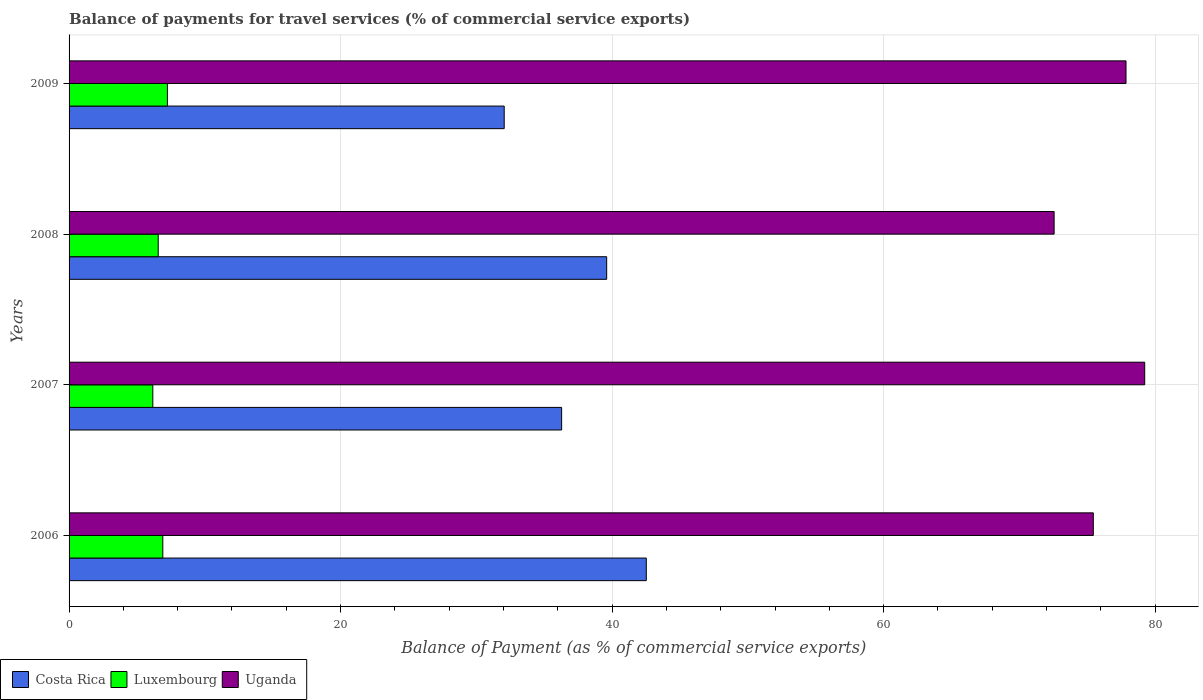How many different coloured bars are there?
Provide a short and direct response. 3. Are the number of bars per tick equal to the number of legend labels?
Ensure brevity in your answer.  Yes. Are the number of bars on each tick of the Y-axis equal?
Your response must be concise. Yes. How many bars are there on the 4th tick from the top?
Provide a succinct answer. 3. How many bars are there on the 1st tick from the bottom?
Provide a succinct answer. 3. What is the label of the 1st group of bars from the top?
Ensure brevity in your answer.  2009. What is the balance of payments for travel services in Costa Rica in 2008?
Your answer should be compact. 39.6. Across all years, what is the maximum balance of payments for travel services in Luxembourg?
Your answer should be compact. 7.24. Across all years, what is the minimum balance of payments for travel services in Luxembourg?
Provide a succinct answer. 6.17. In which year was the balance of payments for travel services in Luxembourg maximum?
Give a very brief answer. 2009. What is the total balance of payments for travel services in Costa Rica in the graph?
Your response must be concise. 150.46. What is the difference between the balance of payments for travel services in Luxembourg in 2006 and that in 2009?
Offer a terse response. -0.34. What is the difference between the balance of payments for travel services in Costa Rica in 2009 and the balance of payments for travel services in Luxembourg in 2008?
Give a very brief answer. 25.49. What is the average balance of payments for travel services in Luxembourg per year?
Your answer should be very brief. 6.72. In the year 2009, what is the difference between the balance of payments for travel services in Luxembourg and balance of payments for travel services in Costa Rica?
Give a very brief answer. -24.81. What is the ratio of the balance of payments for travel services in Costa Rica in 2008 to that in 2009?
Offer a very short reply. 1.24. Is the difference between the balance of payments for travel services in Luxembourg in 2008 and 2009 greater than the difference between the balance of payments for travel services in Costa Rica in 2008 and 2009?
Your answer should be compact. No. What is the difference between the highest and the second highest balance of payments for travel services in Costa Rica?
Ensure brevity in your answer.  2.92. What is the difference between the highest and the lowest balance of payments for travel services in Uganda?
Ensure brevity in your answer.  6.67. In how many years, is the balance of payments for travel services in Luxembourg greater than the average balance of payments for travel services in Luxembourg taken over all years?
Your answer should be compact. 2. Is the sum of the balance of payments for travel services in Uganda in 2006 and 2007 greater than the maximum balance of payments for travel services in Luxembourg across all years?
Ensure brevity in your answer.  Yes. What does the 3rd bar from the top in 2008 represents?
Offer a terse response. Costa Rica. Are all the bars in the graph horizontal?
Ensure brevity in your answer.  Yes. How many legend labels are there?
Give a very brief answer. 3. How are the legend labels stacked?
Your response must be concise. Horizontal. What is the title of the graph?
Offer a terse response. Balance of payments for travel services (% of commercial service exports). Does "Jordan" appear as one of the legend labels in the graph?
Provide a short and direct response. No. What is the label or title of the X-axis?
Offer a terse response. Balance of Payment (as % of commercial service exports). What is the label or title of the Y-axis?
Provide a succinct answer. Years. What is the Balance of Payment (as % of commercial service exports) in Costa Rica in 2006?
Give a very brief answer. 42.52. What is the Balance of Payment (as % of commercial service exports) of Luxembourg in 2006?
Provide a short and direct response. 6.91. What is the Balance of Payment (as % of commercial service exports) in Uganda in 2006?
Offer a very short reply. 75.45. What is the Balance of Payment (as % of commercial service exports) of Costa Rica in 2007?
Make the answer very short. 36.28. What is the Balance of Payment (as % of commercial service exports) in Luxembourg in 2007?
Provide a succinct answer. 6.17. What is the Balance of Payment (as % of commercial service exports) of Uganda in 2007?
Provide a short and direct response. 79.23. What is the Balance of Payment (as % of commercial service exports) in Costa Rica in 2008?
Provide a succinct answer. 39.6. What is the Balance of Payment (as % of commercial service exports) in Luxembourg in 2008?
Offer a terse response. 6.57. What is the Balance of Payment (as % of commercial service exports) in Uganda in 2008?
Give a very brief answer. 72.56. What is the Balance of Payment (as % of commercial service exports) in Costa Rica in 2009?
Your response must be concise. 32.05. What is the Balance of Payment (as % of commercial service exports) in Luxembourg in 2009?
Offer a very short reply. 7.24. What is the Balance of Payment (as % of commercial service exports) in Uganda in 2009?
Keep it short and to the point. 77.86. Across all years, what is the maximum Balance of Payment (as % of commercial service exports) in Costa Rica?
Ensure brevity in your answer.  42.52. Across all years, what is the maximum Balance of Payment (as % of commercial service exports) of Luxembourg?
Your answer should be compact. 7.24. Across all years, what is the maximum Balance of Payment (as % of commercial service exports) in Uganda?
Ensure brevity in your answer.  79.23. Across all years, what is the minimum Balance of Payment (as % of commercial service exports) of Costa Rica?
Provide a short and direct response. 32.05. Across all years, what is the minimum Balance of Payment (as % of commercial service exports) of Luxembourg?
Provide a short and direct response. 6.17. Across all years, what is the minimum Balance of Payment (as % of commercial service exports) in Uganda?
Keep it short and to the point. 72.56. What is the total Balance of Payment (as % of commercial service exports) of Costa Rica in the graph?
Your response must be concise. 150.46. What is the total Balance of Payment (as % of commercial service exports) of Luxembourg in the graph?
Provide a short and direct response. 26.89. What is the total Balance of Payment (as % of commercial service exports) in Uganda in the graph?
Provide a succinct answer. 305.1. What is the difference between the Balance of Payment (as % of commercial service exports) in Costa Rica in 2006 and that in 2007?
Provide a short and direct response. 6.24. What is the difference between the Balance of Payment (as % of commercial service exports) of Luxembourg in 2006 and that in 2007?
Your answer should be compact. 0.73. What is the difference between the Balance of Payment (as % of commercial service exports) in Uganda in 2006 and that in 2007?
Make the answer very short. -3.79. What is the difference between the Balance of Payment (as % of commercial service exports) of Costa Rica in 2006 and that in 2008?
Your answer should be very brief. 2.92. What is the difference between the Balance of Payment (as % of commercial service exports) in Luxembourg in 2006 and that in 2008?
Provide a short and direct response. 0.34. What is the difference between the Balance of Payment (as % of commercial service exports) in Uganda in 2006 and that in 2008?
Provide a short and direct response. 2.89. What is the difference between the Balance of Payment (as % of commercial service exports) in Costa Rica in 2006 and that in 2009?
Your answer should be very brief. 10.47. What is the difference between the Balance of Payment (as % of commercial service exports) in Luxembourg in 2006 and that in 2009?
Provide a short and direct response. -0.34. What is the difference between the Balance of Payment (as % of commercial service exports) in Uganda in 2006 and that in 2009?
Keep it short and to the point. -2.41. What is the difference between the Balance of Payment (as % of commercial service exports) in Costa Rica in 2007 and that in 2008?
Your answer should be very brief. -3.32. What is the difference between the Balance of Payment (as % of commercial service exports) in Luxembourg in 2007 and that in 2008?
Provide a short and direct response. -0.4. What is the difference between the Balance of Payment (as % of commercial service exports) in Uganda in 2007 and that in 2008?
Your answer should be very brief. 6.67. What is the difference between the Balance of Payment (as % of commercial service exports) in Costa Rica in 2007 and that in 2009?
Your answer should be compact. 4.23. What is the difference between the Balance of Payment (as % of commercial service exports) of Luxembourg in 2007 and that in 2009?
Provide a short and direct response. -1.07. What is the difference between the Balance of Payment (as % of commercial service exports) of Uganda in 2007 and that in 2009?
Your answer should be compact. 1.38. What is the difference between the Balance of Payment (as % of commercial service exports) in Costa Rica in 2008 and that in 2009?
Make the answer very short. 7.55. What is the difference between the Balance of Payment (as % of commercial service exports) in Luxembourg in 2008 and that in 2009?
Provide a short and direct response. -0.68. What is the difference between the Balance of Payment (as % of commercial service exports) of Uganda in 2008 and that in 2009?
Your response must be concise. -5.3. What is the difference between the Balance of Payment (as % of commercial service exports) of Costa Rica in 2006 and the Balance of Payment (as % of commercial service exports) of Luxembourg in 2007?
Keep it short and to the point. 36.35. What is the difference between the Balance of Payment (as % of commercial service exports) in Costa Rica in 2006 and the Balance of Payment (as % of commercial service exports) in Uganda in 2007?
Keep it short and to the point. -36.71. What is the difference between the Balance of Payment (as % of commercial service exports) in Luxembourg in 2006 and the Balance of Payment (as % of commercial service exports) in Uganda in 2007?
Offer a very short reply. -72.33. What is the difference between the Balance of Payment (as % of commercial service exports) in Costa Rica in 2006 and the Balance of Payment (as % of commercial service exports) in Luxembourg in 2008?
Keep it short and to the point. 35.95. What is the difference between the Balance of Payment (as % of commercial service exports) in Costa Rica in 2006 and the Balance of Payment (as % of commercial service exports) in Uganda in 2008?
Provide a short and direct response. -30.04. What is the difference between the Balance of Payment (as % of commercial service exports) in Luxembourg in 2006 and the Balance of Payment (as % of commercial service exports) in Uganda in 2008?
Your answer should be very brief. -65.66. What is the difference between the Balance of Payment (as % of commercial service exports) in Costa Rica in 2006 and the Balance of Payment (as % of commercial service exports) in Luxembourg in 2009?
Offer a very short reply. 35.27. What is the difference between the Balance of Payment (as % of commercial service exports) in Costa Rica in 2006 and the Balance of Payment (as % of commercial service exports) in Uganda in 2009?
Provide a short and direct response. -35.34. What is the difference between the Balance of Payment (as % of commercial service exports) of Luxembourg in 2006 and the Balance of Payment (as % of commercial service exports) of Uganda in 2009?
Make the answer very short. -70.95. What is the difference between the Balance of Payment (as % of commercial service exports) of Costa Rica in 2007 and the Balance of Payment (as % of commercial service exports) of Luxembourg in 2008?
Provide a succinct answer. 29.72. What is the difference between the Balance of Payment (as % of commercial service exports) in Costa Rica in 2007 and the Balance of Payment (as % of commercial service exports) in Uganda in 2008?
Make the answer very short. -36.28. What is the difference between the Balance of Payment (as % of commercial service exports) of Luxembourg in 2007 and the Balance of Payment (as % of commercial service exports) of Uganda in 2008?
Your answer should be compact. -66.39. What is the difference between the Balance of Payment (as % of commercial service exports) in Costa Rica in 2007 and the Balance of Payment (as % of commercial service exports) in Luxembourg in 2009?
Provide a succinct answer. 29.04. What is the difference between the Balance of Payment (as % of commercial service exports) of Costa Rica in 2007 and the Balance of Payment (as % of commercial service exports) of Uganda in 2009?
Your answer should be compact. -41.57. What is the difference between the Balance of Payment (as % of commercial service exports) of Luxembourg in 2007 and the Balance of Payment (as % of commercial service exports) of Uganda in 2009?
Your response must be concise. -71.69. What is the difference between the Balance of Payment (as % of commercial service exports) in Costa Rica in 2008 and the Balance of Payment (as % of commercial service exports) in Luxembourg in 2009?
Offer a terse response. 32.36. What is the difference between the Balance of Payment (as % of commercial service exports) in Costa Rica in 2008 and the Balance of Payment (as % of commercial service exports) in Uganda in 2009?
Provide a succinct answer. -38.26. What is the difference between the Balance of Payment (as % of commercial service exports) in Luxembourg in 2008 and the Balance of Payment (as % of commercial service exports) in Uganda in 2009?
Ensure brevity in your answer.  -71.29. What is the average Balance of Payment (as % of commercial service exports) in Costa Rica per year?
Give a very brief answer. 37.61. What is the average Balance of Payment (as % of commercial service exports) in Luxembourg per year?
Offer a terse response. 6.72. What is the average Balance of Payment (as % of commercial service exports) in Uganda per year?
Your response must be concise. 76.27. In the year 2006, what is the difference between the Balance of Payment (as % of commercial service exports) in Costa Rica and Balance of Payment (as % of commercial service exports) in Luxembourg?
Make the answer very short. 35.61. In the year 2006, what is the difference between the Balance of Payment (as % of commercial service exports) in Costa Rica and Balance of Payment (as % of commercial service exports) in Uganda?
Give a very brief answer. -32.93. In the year 2006, what is the difference between the Balance of Payment (as % of commercial service exports) of Luxembourg and Balance of Payment (as % of commercial service exports) of Uganda?
Your answer should be very brief. -68.54. In the year 2007, what is the difference between the Balance of Payment (as % of commercial service exports) in Costa Rica and Balance of Payment (as % of commercial service exports) in Luxembourg?
Give a very brief answer. 30.11. In the year 2007, what is the difference between the Balance of Payment (as % of commercial service exports) of Costa Rica and Balance of Payment (as % of commercial service exports) of Uganda?
Provide a short and direct response. -42.95. In the year 2007, what is the difference between the Balance of Payment (as % of commercial service exports) of Luxembourg and Balance of Payment (as % of commercial service exports) of Uganda?
Your response must be concise. -73.06. In the year 2008, what is the difference between the Balance of Payment (as % of commercial service exports) in Costa Rica and Balance of Payment (as % of commercial service exports) in Luxembourg?
Ensure brevity in your answer.  33.03. In the year 2008, what is the difference between the Balance of Payment (as % of commercial service exports) in Costa Rica and Balance of Payment (as % of commercial service exports) in Uganda?
Give a very brief answer. -32.96. In the year 2008, what is the difference between the Balance of Payment (as % of commercial service exports) of Luxembourg and Balance of Payment (as % of commercial service exports) of Uganda?
Keep it short and to the point. -65.99. In the year 2009, what is the difference between the Balance of Payment (as % of commercial service exports) of Costa Rica and Balance of Payment (as % of commercial service exports) of Luxembourg?
Keep it short and to the point. 24.81. In the year 2009, what is the difference between the Balance of Payment (as % of commercial service exports) of Costa Rica and Balance of Payment (as % of commercial service exports) of Uganda?
Your answer should be compact. -45.8. In the year 2009, what is the difference between the Balance of Payment (as % of commercial service exports) in Luxembourg and Balance of Payment (as % of commercial service exports) in Uganda?
Ensure brevity in your answer.  -70.61. What is the ratio of the Balance of Payment (as % of commercial service exports) of Costa Rica in 2006 to that in 2007?
Ensure brevity in your answer.  1.17. What is the ratio of the Balance of Payment (as % of commercial service exports) in Luxembourg in 2006 to that in 2007?
Provide a succinct answer. 1.12. What is the ratio of the Balance of Payment (as % of commercial service exports) in Uganda in 2006 to that in 2007?
Your answer should be very brief. 0.95. What is the ratio of the Balance of Payment (as % of commercial service exports) in Costa Rica in 2006 to that in 2008?
Give a very brief answer. 1.07. What is the ratio of the Balance of Payment (as % of commercial service exports) in Luxembourg in 2006 to that in 2008?
Give a very brief answer. 1.05. What is the ratio of the Balance of Payment (as % of commercial service exports) of Uganda in 2006 to that in 2008?
Make the answer very short. 1.04. What is the ratio of the Balance of Payment (as % of commercial service exports) in Costa Rica in 2006 to that in 2009?
Give a very brief answer. 1.33. What is the ratio of the Balance of Payment (as % of commercial service exports) in Luxembourg in 2006 to that in 2009?
Your answer should be compact. 0.95. What is the ratio of the Balance of Payment (as % of commercial service exports) in Uganda in 2006 to that in 2009?
Offer a terse response. 0.97. What is the ratio of the Balance of Payment (as % of commercial service exports) of Costa Rica in 2007 to that in 2008?
Offer a terse response. 0.92. What is the ratio of the Balance of Payment (as % of commercial service exports) of Luxembourg in 2007 to that in 2008?
Provide a succinct answer. 0.94. What is the ratio of the Balance of Payment (as % of commercial service exports) in Uganda in 2007 to that in 2008?
Keep it short and to the point. 1.09. What is the ratio of the Balance of Payment (as % of commercial service exports) of Costa Rica in 2007 to that in 2009?
Provide a short and direct response. 1.13. What is the ratio of the Balance of Payment (as % of commercial service exports) in Luxembourg in 2007 to that in 2009?
Your response must be concise. 0.85. What is the ratio of the Balance of Payment (as % of commercial service exports) of Uganda in 2007 to that in 2009?
Keep it short and to the point. 1.02. What is the ratio of the Balance of Payment (as % of commercial service exports) in Costa Rica in 2008 to that in 2009?
Your answer should be compact. 1.24. What is the ratio of the Balance of Payment (as % of commercial service exports) in Luxembourg in 2008 to that in 2009?
Your answer should be very brief. 0.91. What is the ratio of the Balance of Payment (as % of commercial service exports) in Uganda in 2008 to that in 2009?
Offer a terse response. 0.93. What is the difference between the highest and the second highest Balance of Payment (as % of commercial service exports) in Costa Rica?
Provide a short and direct response. 2.92. What is the difference between the highest and the second highest Balance of Payment (as % of commercial service exports) in Luxembourg?
Offer a terse response. 0.34. What is the difference between the highest and the second highest Balance of Payment (as % of commercial service exports) in Uganda?
Give a very brief answer. 1.38. What is the difference between the highest and the lowest Balance of Payment (as % of commercial service exports) in Costa Rica?
Provide a short and direct response. 10.47. What is the difference between the highest and the lowest Balance of Payment (as % of commercial service exports) in Luxembourg?
Ensure brevity in your answer.  1.07. What is the difference between the highest and the lowest Balance of Payment (as % of commercial service exports) of Uganda?
Provide a succinct answer. 6.67. 